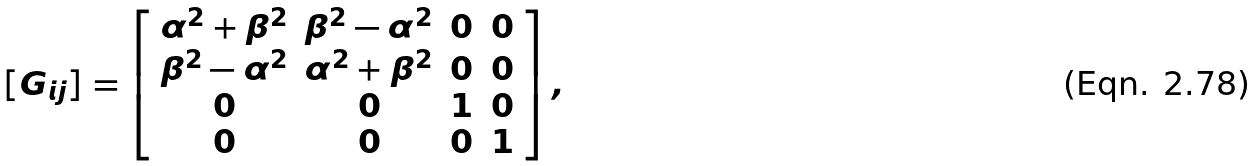Convert formula to latex. <formula><loc_0><loc_0><loc_500><loc_500>[ G _ { i j } ] = \left [ \begin{array} { c c c c } \alpha ^ { 2 } + \beta ^ { 2 } & \beta ^ { 2 } - \alpha ^ { 2 } & 0 & 0 \\ \beta ^ { 2 } - \alpha ^ { 2 } & \alpha ^ { 2 } + \beta ^ { 2 } & 0 & 0 \\ 0 & 0 & 1 & 0 \\ 0 & 0 & 0 & 1 \end{array} \right ] ,</formula> 